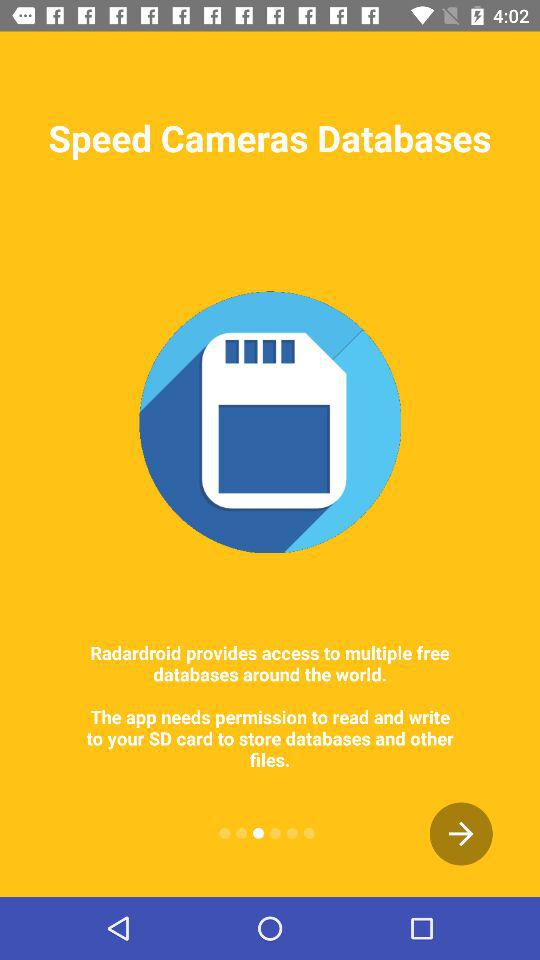What is the application name? The application name is "Radardroid". 